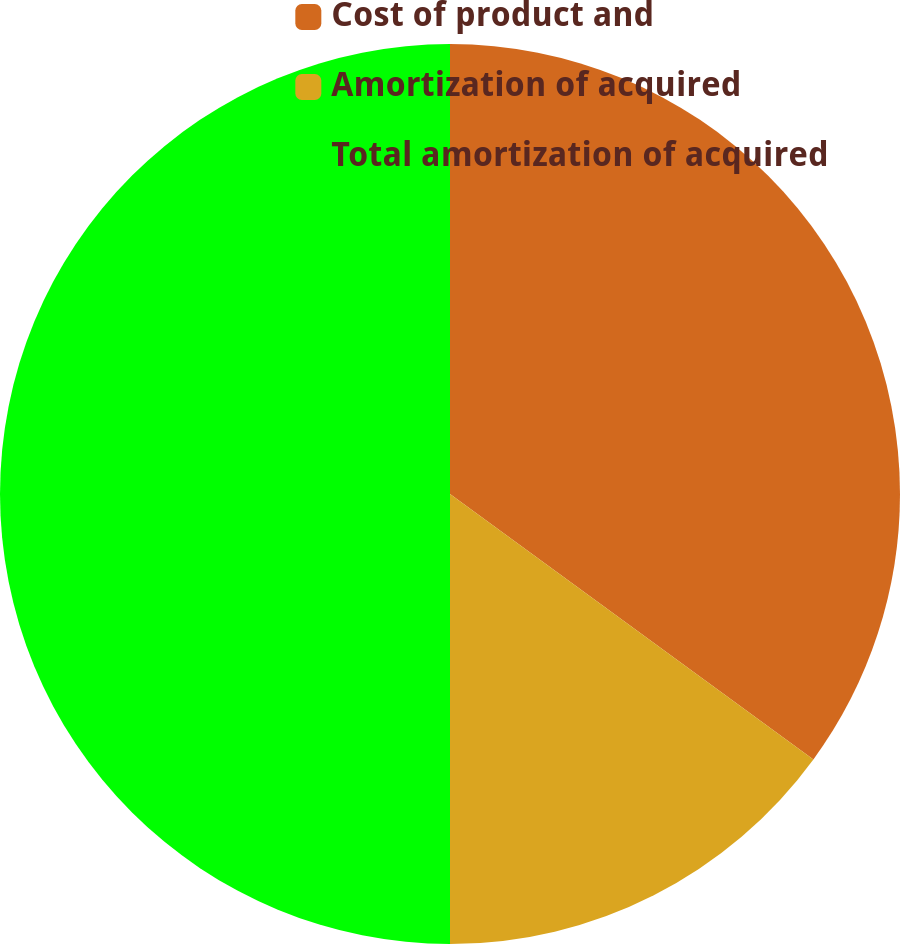Convert chart to OTSL. <chart><loc_0><loc_0><loc_500><loc_500><pie_chart><fcel>Cost of product and<fcel>Amortization of acquired<fcel>Total amortization of acquired<nl><fcel>35.04%<fcel>14.96%<fcel>50.0%<nl></chart> 